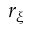Convert formula to latex. <formula><loc_0><loc_0><loc_500><loc_500>r _ { \xi }</formula> 